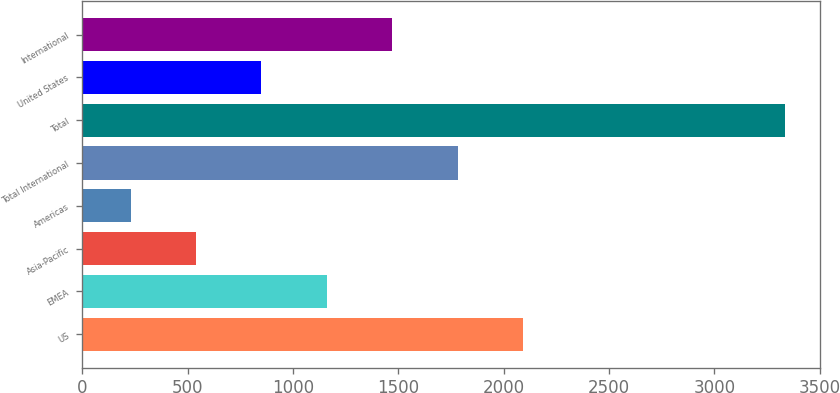Convert chart. <chart><loc_0><loc_0><loc_500><loc_500><bar_chart><fcel>US<fcel>EMEA<fcel>Asia-Pacific<fcel>Americas<fcel>Total International<fcel>Total<fcel>United States<fcel>International<nl><fcel>2092.06<fcel>1160.38<fcel>539.26<fcel>228.7<fcel>1781.5<fcel>3334.3<fcel>849.82<fcel>1470.94<nl></chart> 